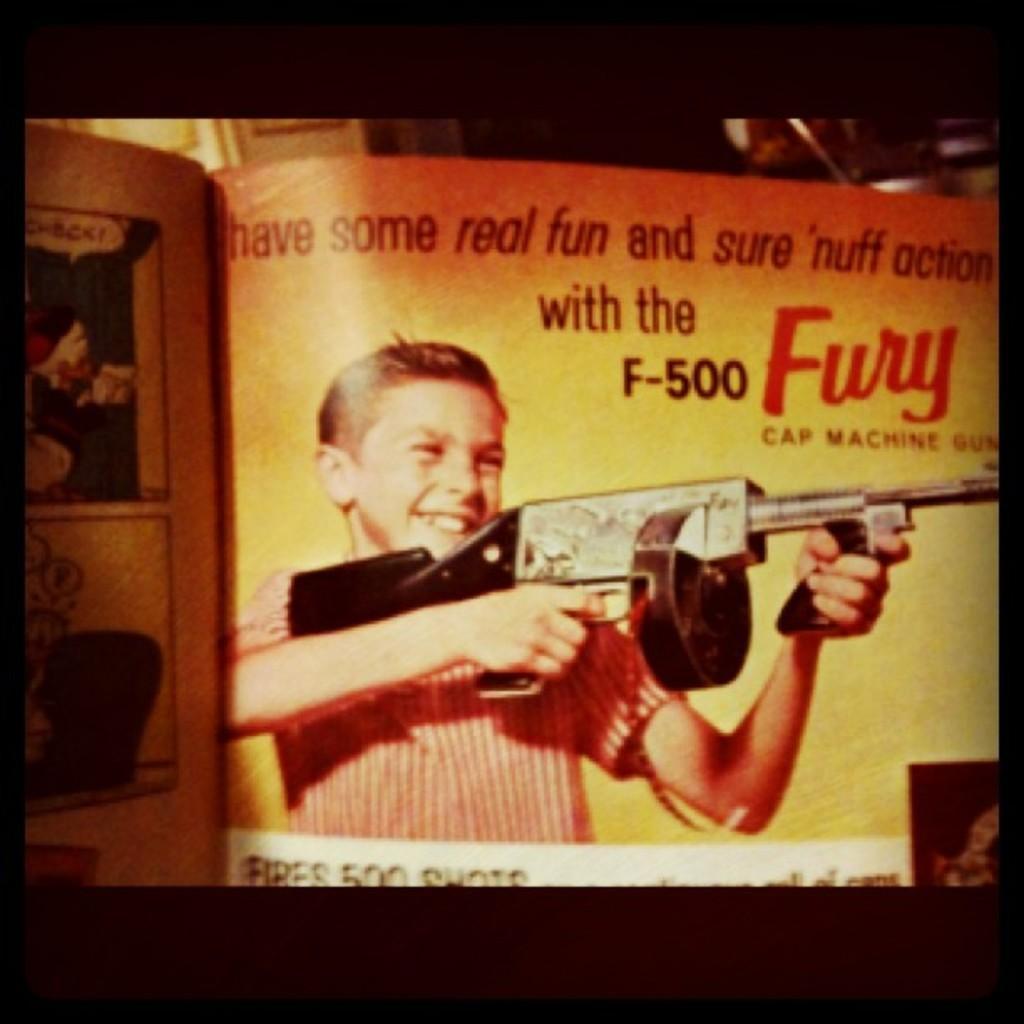Can you describe this image briefly? This image looks like a book there is a depiction of person and there is text in the foreground. And there are objects in the background. 